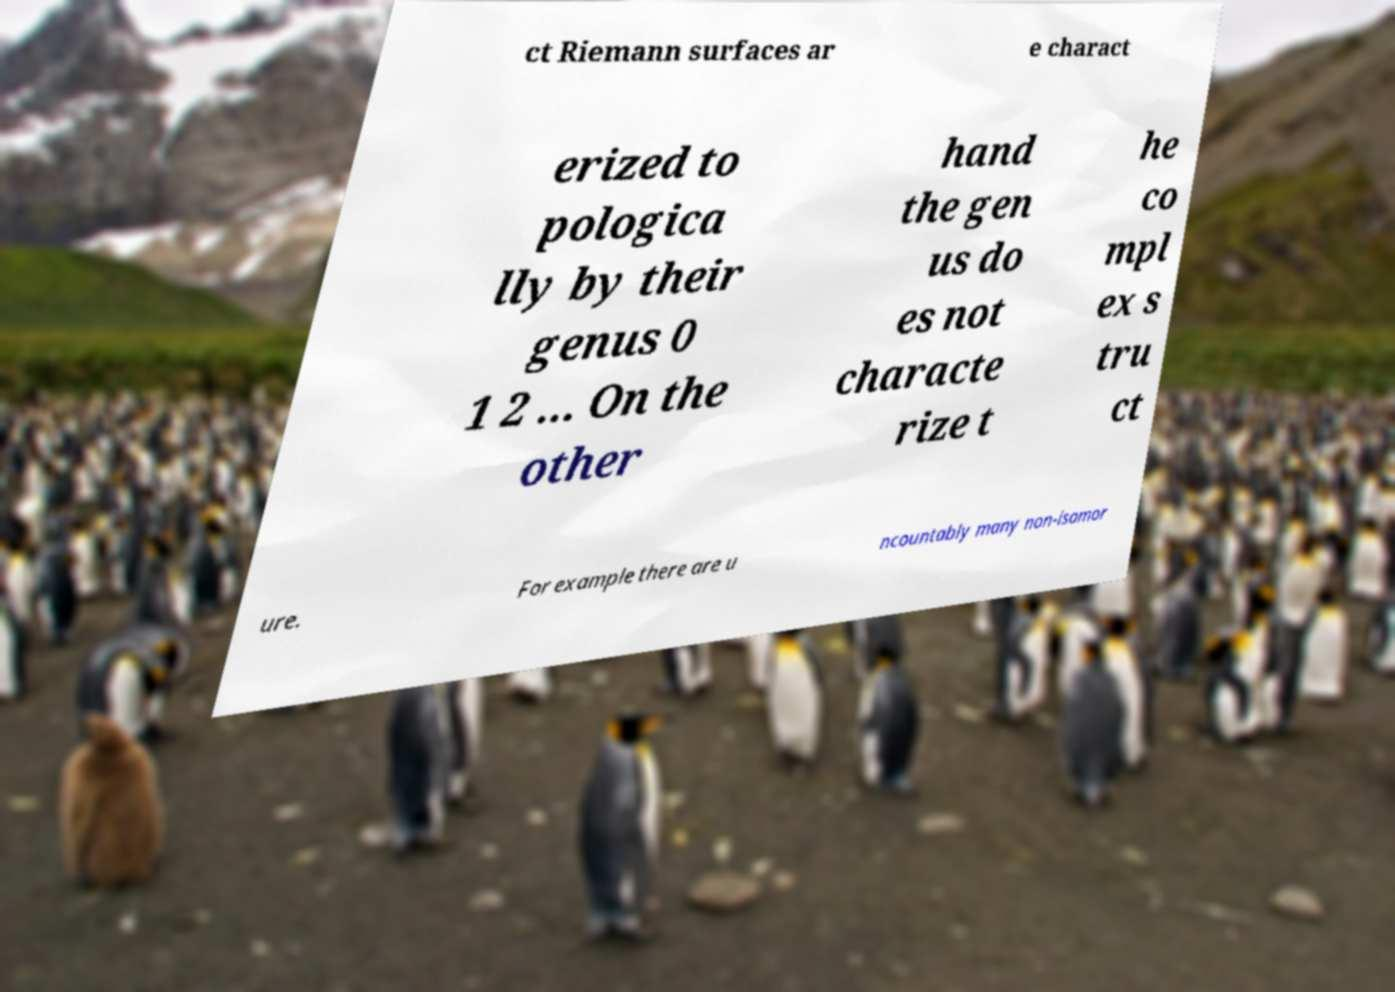There's text embedded in this image that I need extracted. Can you transcribe it verbatim? ct Riemann surfaces ar e charact erized to pologica lly by their genus 0 1 2 ... On the other hand the gen us do es not characte rize t he co mpl ex s tru ct ure. For example there are u ncountably many non-isomor 